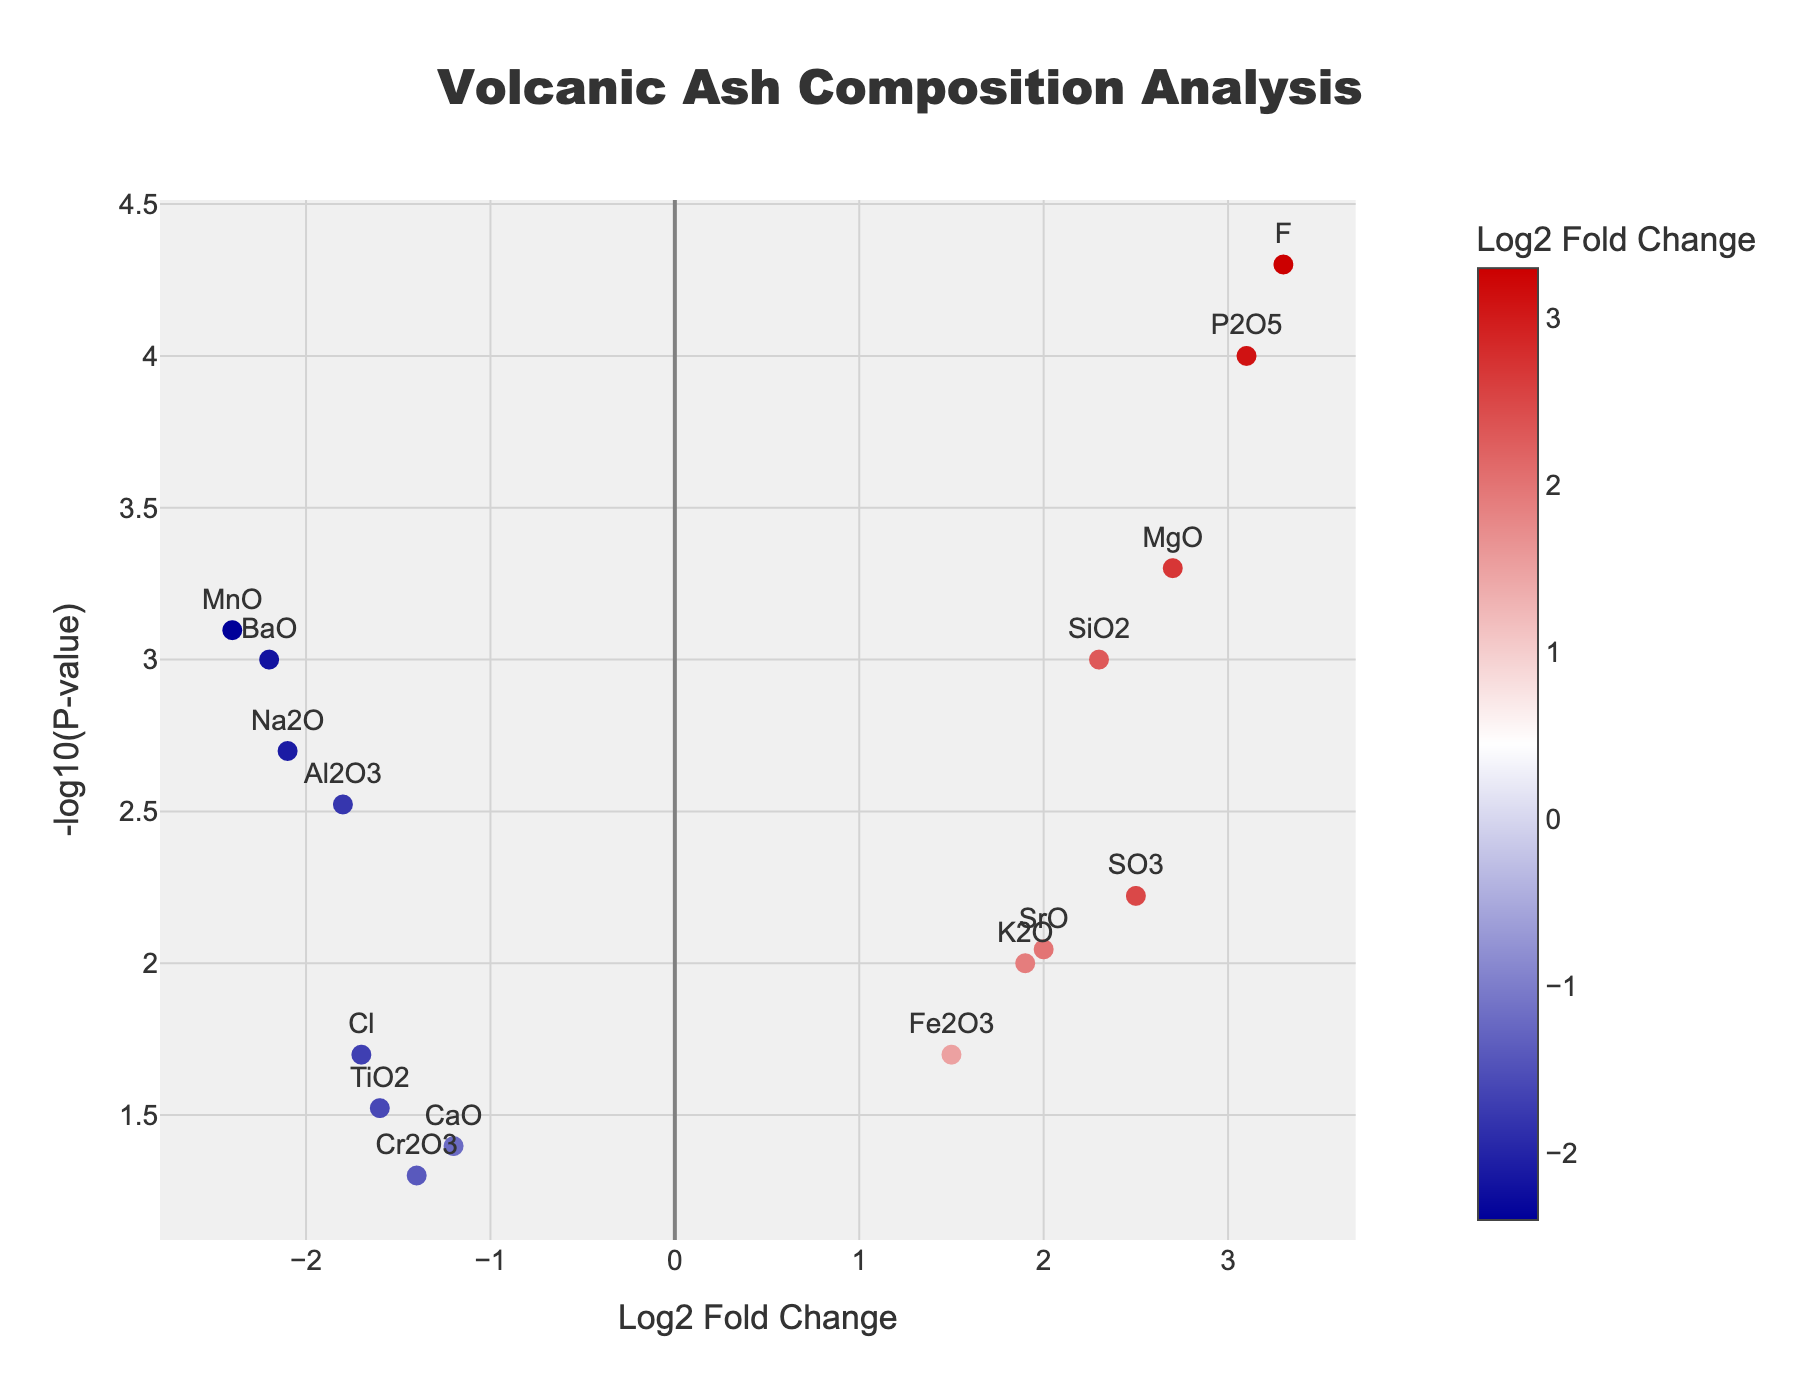What is the title of the plot? The title of the plot is written at the top and is usually a large text that gives an overview of what the plot is about. Here, the title is centrally placed at the top of the figure and reads "Volcanic Ash Composition Analysis".
Answer: Volcanic Ash Composition Analysis What is represented on the x-axis? The x-axis generally represents one of the key dimensions of the data being displayed. In this plot, the x-axis title is "Log2 Fold Change", indicating it shows the Log2 Fold Change values of the elements.
Answer: Log2 Fold Change Which element has the highest -log10(P-value) and what is the corresponding log2 fold change (LogFC)? To find this, look for the point with the highest position on the y-axis and note down the text label (which represents the element) and the x-coordinate (representing the Log2 Fold Change). The highest point is "Hunga Tonga, F", located at `LogFC = 3.3`.
Answer: Hunga Tonga, F; 3.3 How many data points have a positive Log2 Fold Change? Count all the data points that lie to the right of the zero value on the x-axis, as these represent positive Log2 Fold Change values. In this plot, there are 9 such points.
Answer: 9 What is the element with the lowest Log2 Fold Change and what volcano is it from? Look at the points farthest to the left on the x-axis to determine the lowest Log2 Fold Change. The lowest Log2 Fold Change is `-2.4` for the element MnO from the Tavurvur volcano.
Answer: MnO; Tavurvur Which volcano has the most elements with a negative Log2 Fold Change? Look through the hover text or labels for the points on the left side of the x-axis. The volcano with the most points in this region is Yasur with 2 elements (Na2O and Fe2O3).
Answer: Yasur Compare the -log10(P-value) of SiO2 from Kilauea and K2O from Tofua. Which one is larger? Identify the points for SiO2 from Kilauea and K2O from Tofua and compare their y-coordinates. SiO2 from Kilauea is higher at 3 (-log10(0.001) = 3) compared to K2O from Tofua at 2 (-log10(0.01) = 2).
Answer: SiO2 from Kilauea Which element has the highest log2 fold change (LogFC) and what is its p-value? Look for the element that is positioned farthest to the right on the x-axis. The farthest right point is `LogFC = 3.3`, representing F from Hunga Tonga, with a p-value of `0.00005`.
Answer: Hunga Tonga, F; 0.00005 